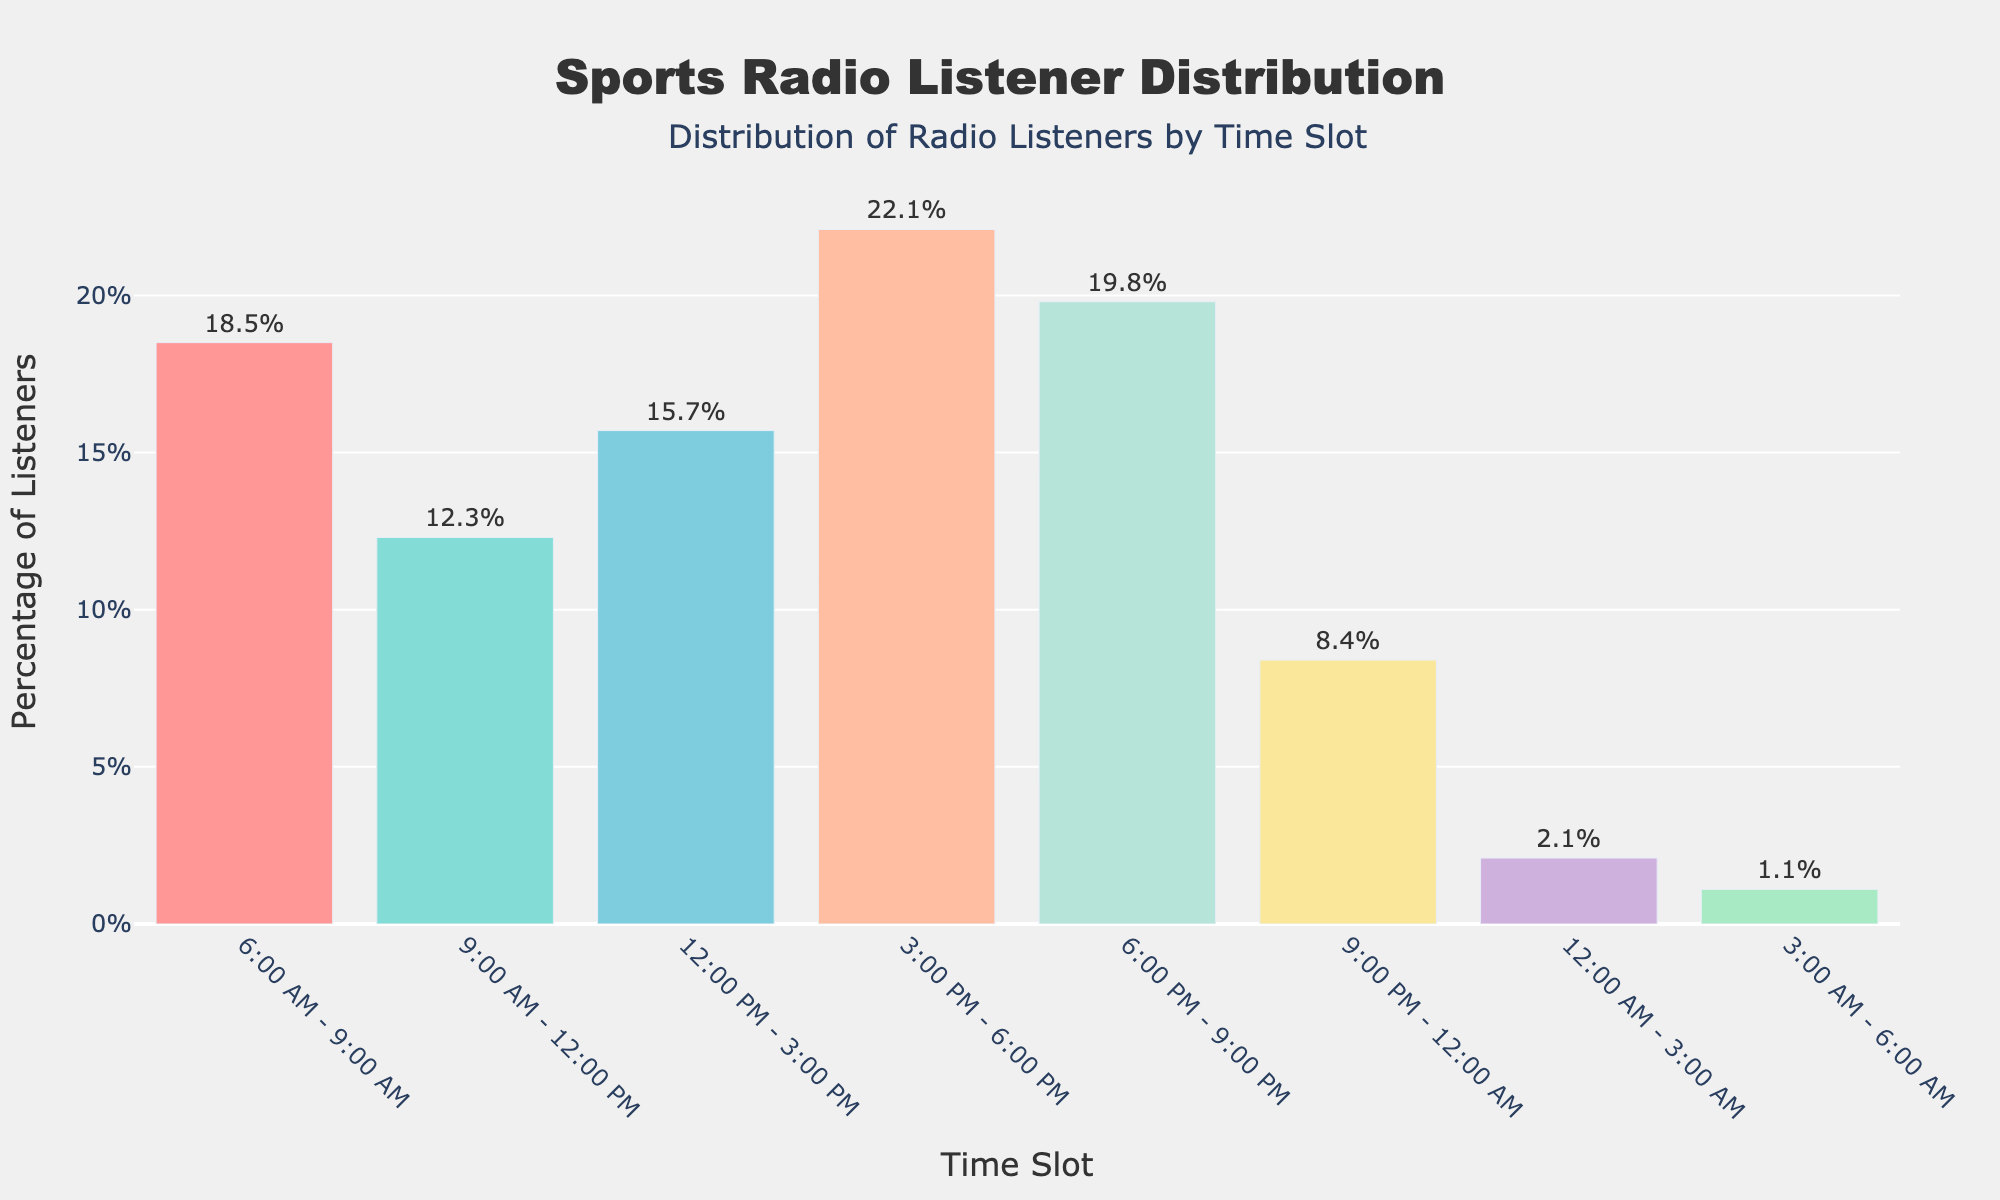What's the most popular time slot for sports radio listeners? The bar representing the *3:00 PM - 6:00 PM* time slot is the tallest, indicating it has the highest percentage of listeners.
Answer: 3:00 PM - 6:00 PM What's the least popular time slot for sports radio listeners? The bar representing the *3:00 AM - 6:00 AM* time slot is the shortest, indicating it has the lowest percentage of listeners.
Answer: 3:00 AM - 6:00 AM How many time slots have more than 15% of listeners? The bars for the *6:00 AM - 9:00 AM*, *3:00 PM - 6:00 PM*, and *6:00 PM - 9:00 PM* time slots surpass 15%, and *12:00 PM - 3:00 PM* is also above 15%. So, there are four time slots with more than 15% listeners.
Answer: Four What's the combined percentage of listeners for the time slots from 6:00 AM to 12:00 PM? The percentages for the *6:00 AM - 9:00 AM* and *9:00 AM - 12:00 PM* time slots are 18.5% and 12.3%, respectively. Adding them together gives 18.5 + 12.3 = 30.8%.
Answer: 30.8% What's the percentage difference between the most popular and least popular time slots? The percentage for the *3:00 PM - 6:00 PM* time slot is 22.1%, and for the *3:00 AM - 6:00 AM* time slot is 1.1%. The difference is 22.1 - 1.1 = 21%.
Answer: 21% Which time slot has a higher percentage of listeners, *9:00 PM - 12:00 AM* or *12:00 AM - 3:00 AM*? The percentage for *9:00 PM - 12:00 AM* is 8.4%, and for *12:00 AM - 3:00 AM* is 2.1%. So, *9:00 PM - 12:00 AM* has a higher percentage.
Answer: 9:00 PM - 12:00 AM Arrange the evening time slots (6:00 PM - 12:00 AM) in order of listener percentage from highest to lowest. The percentages are: *6:00 PM - 9:00 PM: 19.8%*, *9:00 PM - 12:00 AM: 8.4%*. Therefore, the order is *6:00 PM - 9:00 PM* followed by *9:00 PM - 12:00 AM*.
Answer: 6:00 PM - 9:00 PM, 9:00 PM - 12:00 AM What is the average percentage of listeners for the time slots between 12:00 PM to 9:00 PM? The percentages are: *12:00 PM - 3:00 PM: 15.7%*, *3:00 PM - 6:00 PM: 22.1%*, *6:00 PM - 9:00 PM: 19.8%*. The average is (15.7 + 22.1 + 19.8) / 3 = 19.2%.
Answer: 19.2% What is the total percentage of listeners for the overnight time slots (12:00 AM - 6:00 AM)? The percentages for *12:00 AM - 3:00 AM* and *3:00 AM - 6:00 AM* are 2.1% and 1.1%, respectively. Adding them together gives 2.1 + 1.1 = 3.2%.
Answer: 3.2% 